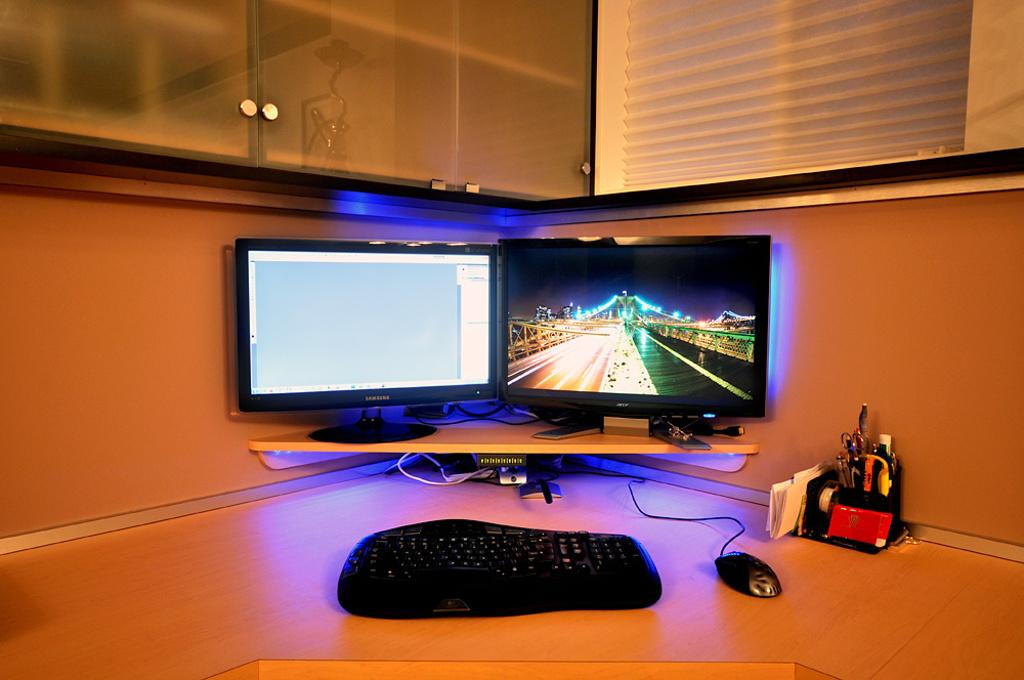What electronic devices are on the desk in the image? There are two monitors, a keyboard, and a mouse on the desk in the image. What other items might be present on the desk? There are other articles on the desk in the image. Where is the desk located in the room? The desk is located in a corner of a room. Can you see a monkey playing with the keyboard in the image? No, there is no monkey present in the image. Is there a recess in the desk for storing items? The image does not provide information about the design of the desk, so it cannot be determined if there is a recess for storing items. 